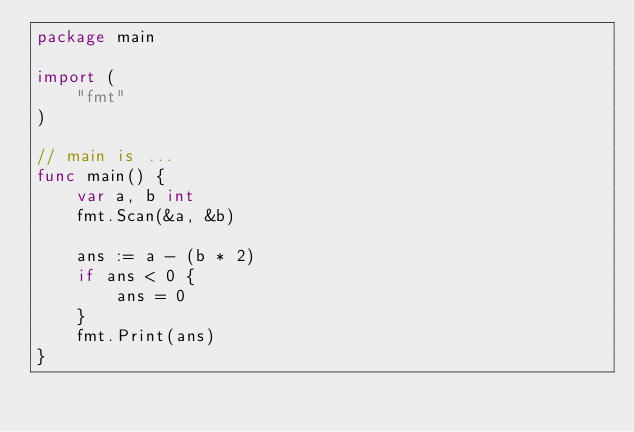<code> <loc_0><loc_0><loc_500><loc_500><_Go_>package main

import (
	"fmt"
)

// main is ...
func main() {
	var a, b int
	fmt.Scan(&a, &b)

	ans := a - (b * 2)
	if ans < 0 {
		ans = 0
	}
	fmt.Print(ans)
}

</code> 